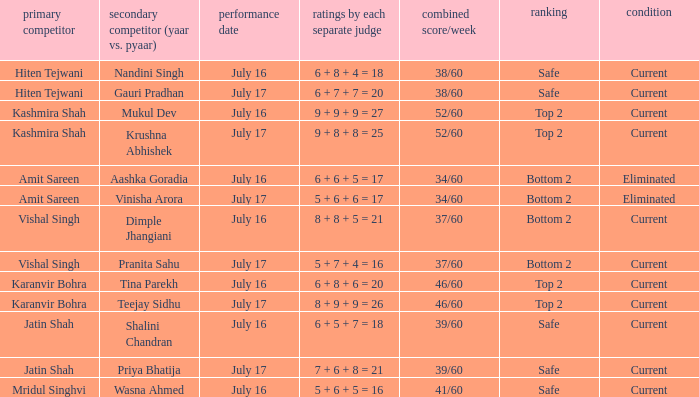What date did Jatin Shah and Shalini Chandran perform? July 16. 